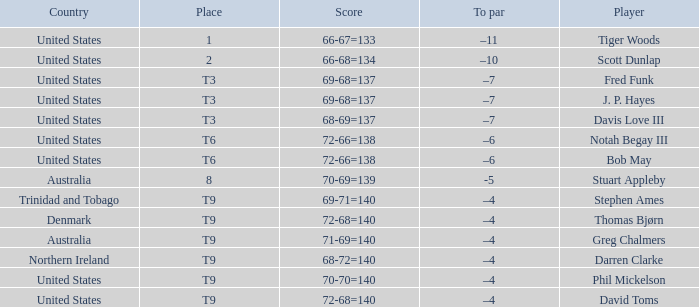What is the To par value that goes with a Score of 70-69=139? -5.0. 